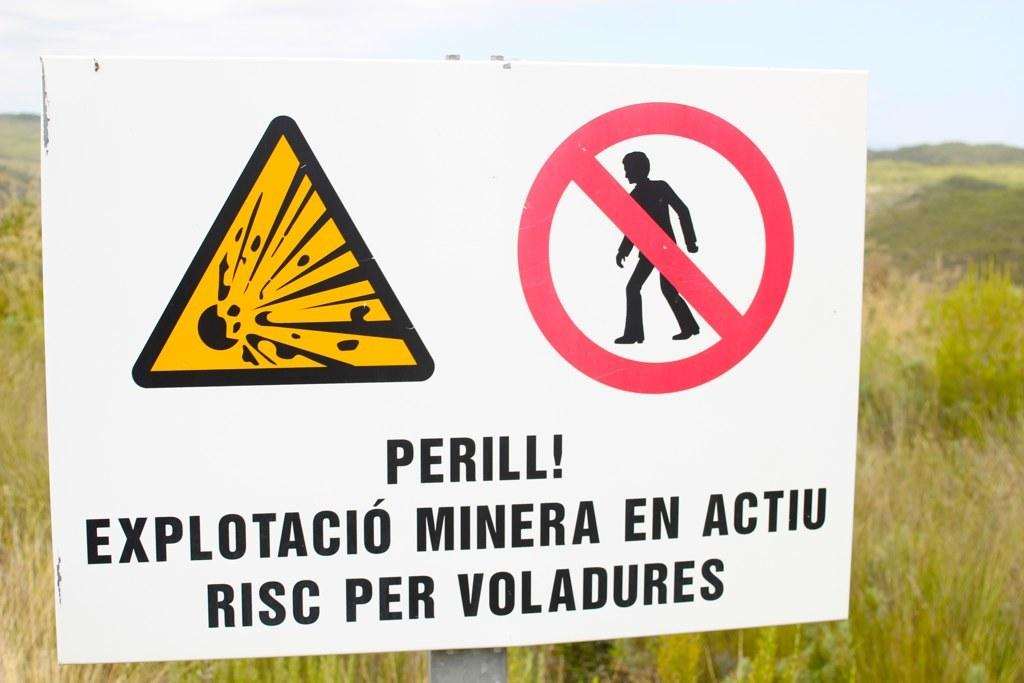What is the main object in the center of the image? There is a sign board in the center of the image. What can be found on the sign board? There is writing on the sign board. What can be seen in the background of the image? The sky, clouds, plants, and grass are visible in the background of the image. What type of quilt is being used to cover the plants in the image? There is no quilt present in the image; plants are visible in the background without any covering. What kind of songs can be heard coming from the clouds in the image? There is no indication of any songs or sounds in the image, as it only features a sign board, writing, and the background elements. 